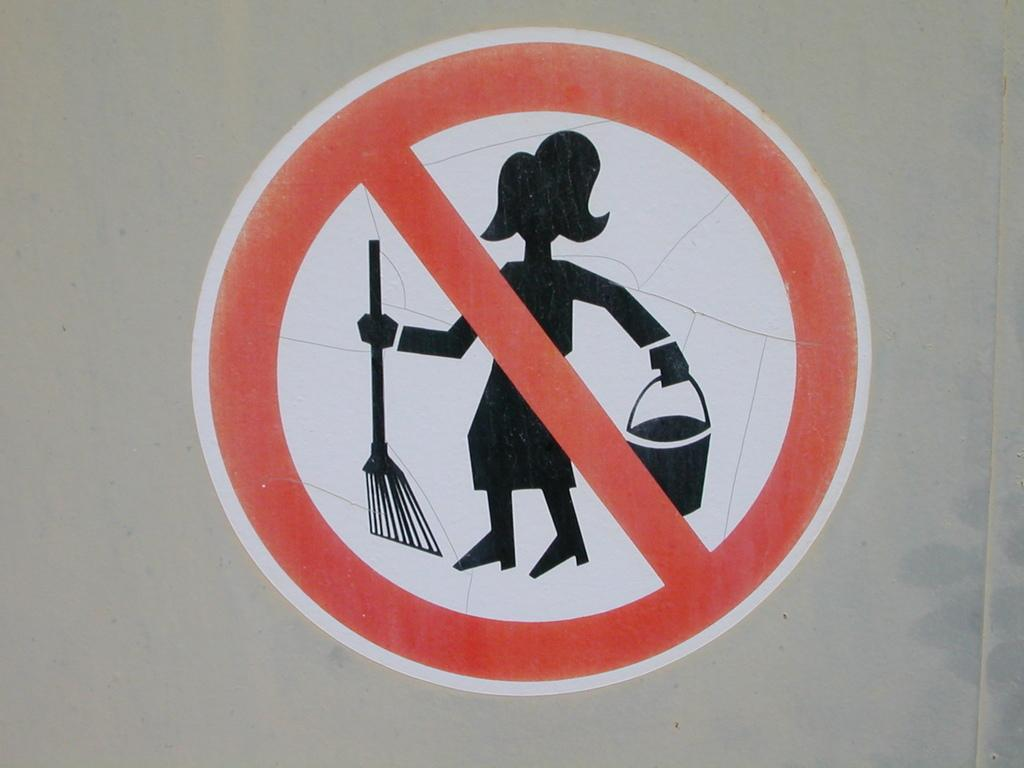What is the main object in the image? There is a sign board in the image. Where is the sign board located? The sign board is on a surface. What types of toys can be seen playing with a ball in the image? There are no toys or balls present in the image; it only features a sign board on a surface. 